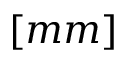<formula> <loc_0><loc_0><loc_500><loc_500>[ m m ]</formula> 